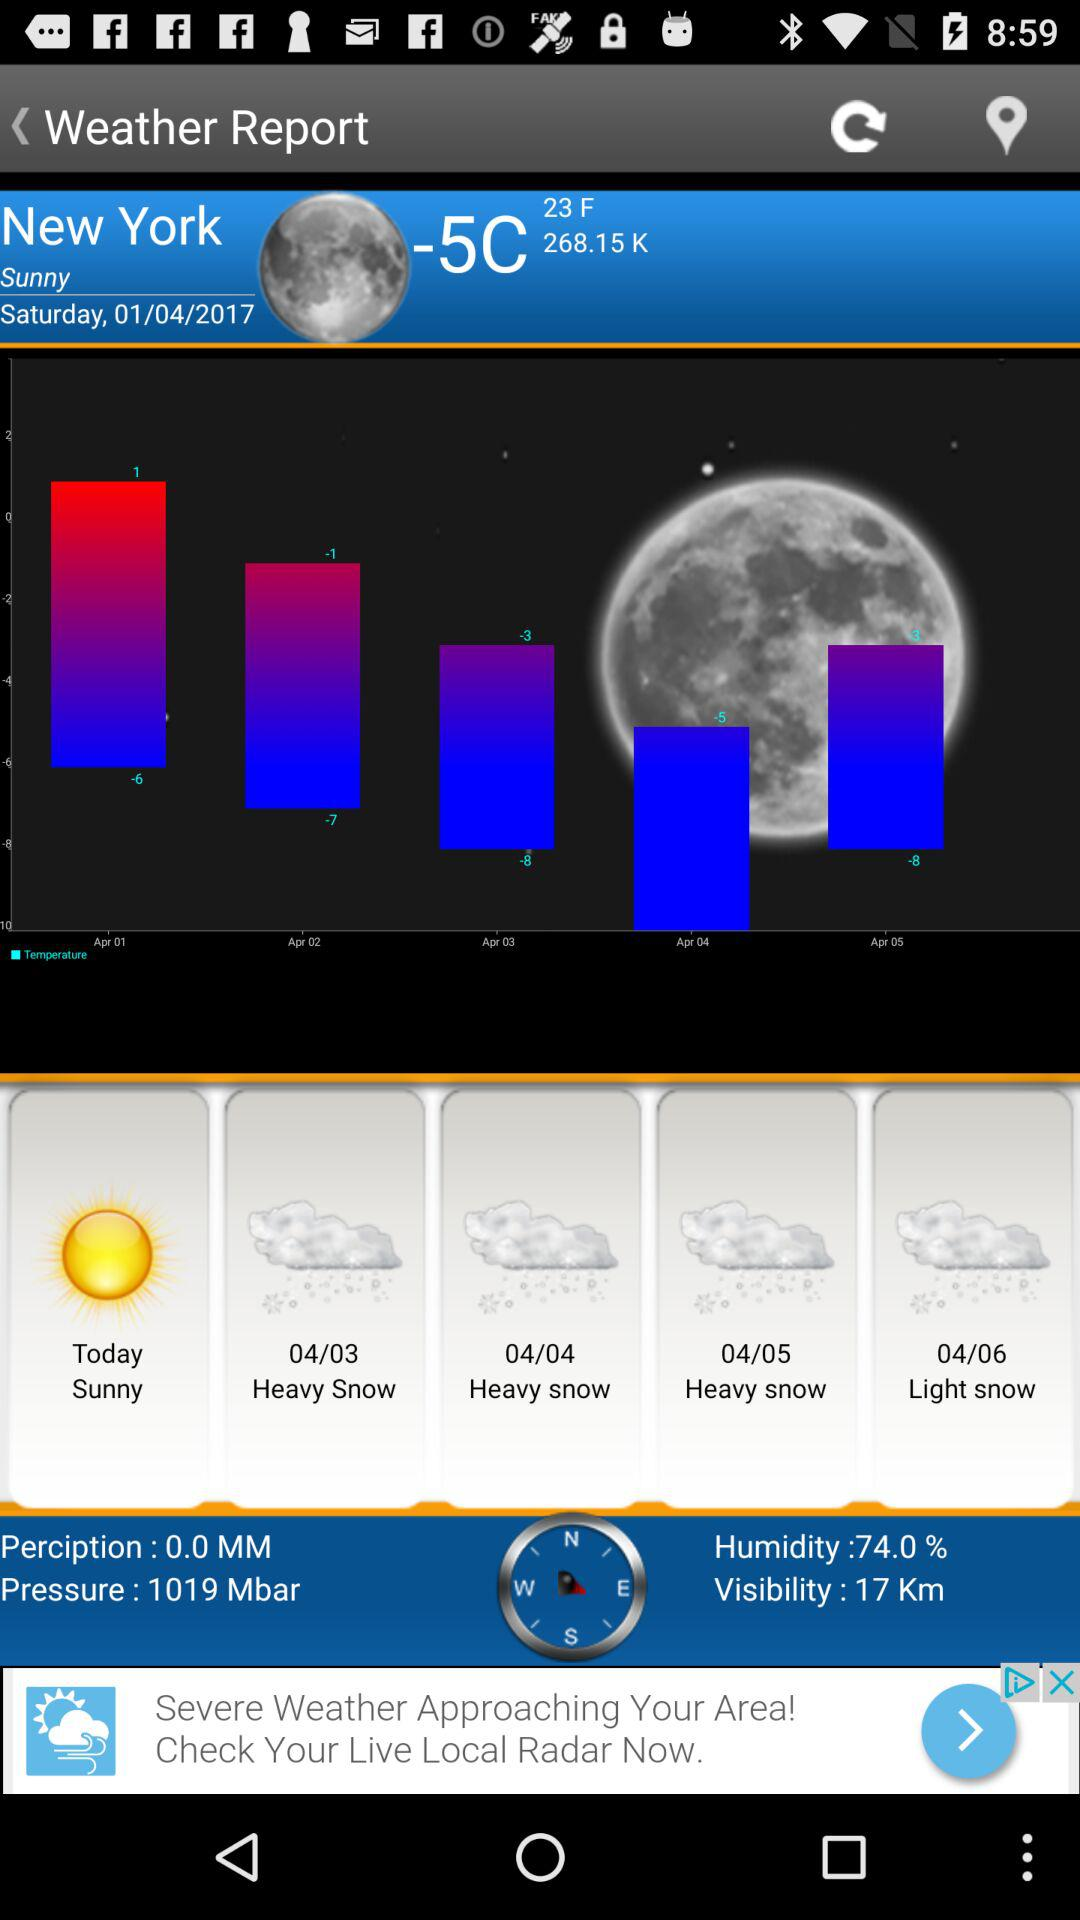What is the humidity?
Answer the question using a single word or phrase. 74.0% 